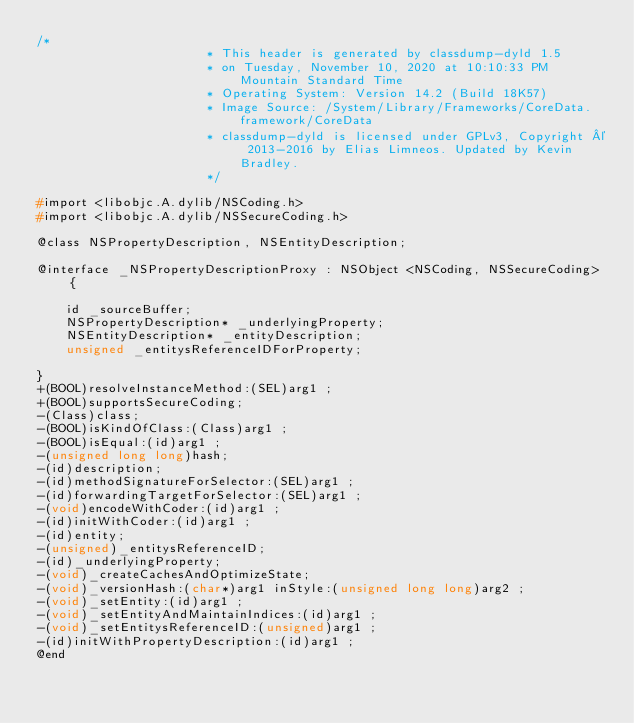Convert code to text. <code><loc_0><loc_0><loc_500><loc_500><_C_>/*
                       * This header is generated by classdump-dyld 1.5
                       * on Tuesday, November 10, 2020 at 10:10:33 PM Mountain Standard Time
                       * Operating System: Version 14.2 (Build 18K57)
                       * Image Source: /System/Library/Frameworks/CoreData.framework/CoreData
                       * classdump-dyld is licensed under GPLv3, Copyright © 2013-2016 by Elias Limneos. Updated by Kevin Bradley.
                       */

#import <libobjc.A.dylib/NSCoding.h>
#import <libobjc.A.dylib/NSSecureCoding.h>

@class NSPropertyDescription, NSEntityDescription;

@interface _NSPropertyDescriptionProxy : NSObject <NSCoding, NSSecureCoding> {

	id _sourceBuffer;
	NSPropertyDescription* _underlyingProperty;
	NSEntityDescription* _entityDescription;
	unsigned _entitysReferenceIDForProperty;

}
+(BOOL)resolveInstanceMethod:(SEL)arg1 ;
+(BOOL)supportsSecureCoding;
-(Class)class;
-(BOOL)isKindOfClass:(Class)arg1 ;
-(BOOL)isEqual:(id)arg1 ;
-(unsigned long long)hash;
-(id)description;
-(id)methodSignatureForSelector:(SEL)arg1 ;
-(id)forwardingTargetForSelector:(SEL)arg1 ;
-(void)encodeWithCoder:(id)arg1 ;
-(id)initWithCoder:(id)arg1 ;
-(id)entity;
-(unsigned)_entitysReferenceID;
-(id)_underlyingProperty;
-(void)_createCachesAndOptimizeState;
-(void)_versionHash:(char*)arg1 inStyle:(unsigned long long)arg2 ;
-(void)_setEntity:(id)arg1 ;
-(void)_setEntityAndMaintainIndices:(id)arg1 ;
-(void)_setEntitysReferenceID:(unsigned)arg1 ;
-(id)initWithPropertyDescription:(id)arg1 ;
@end

</code> 